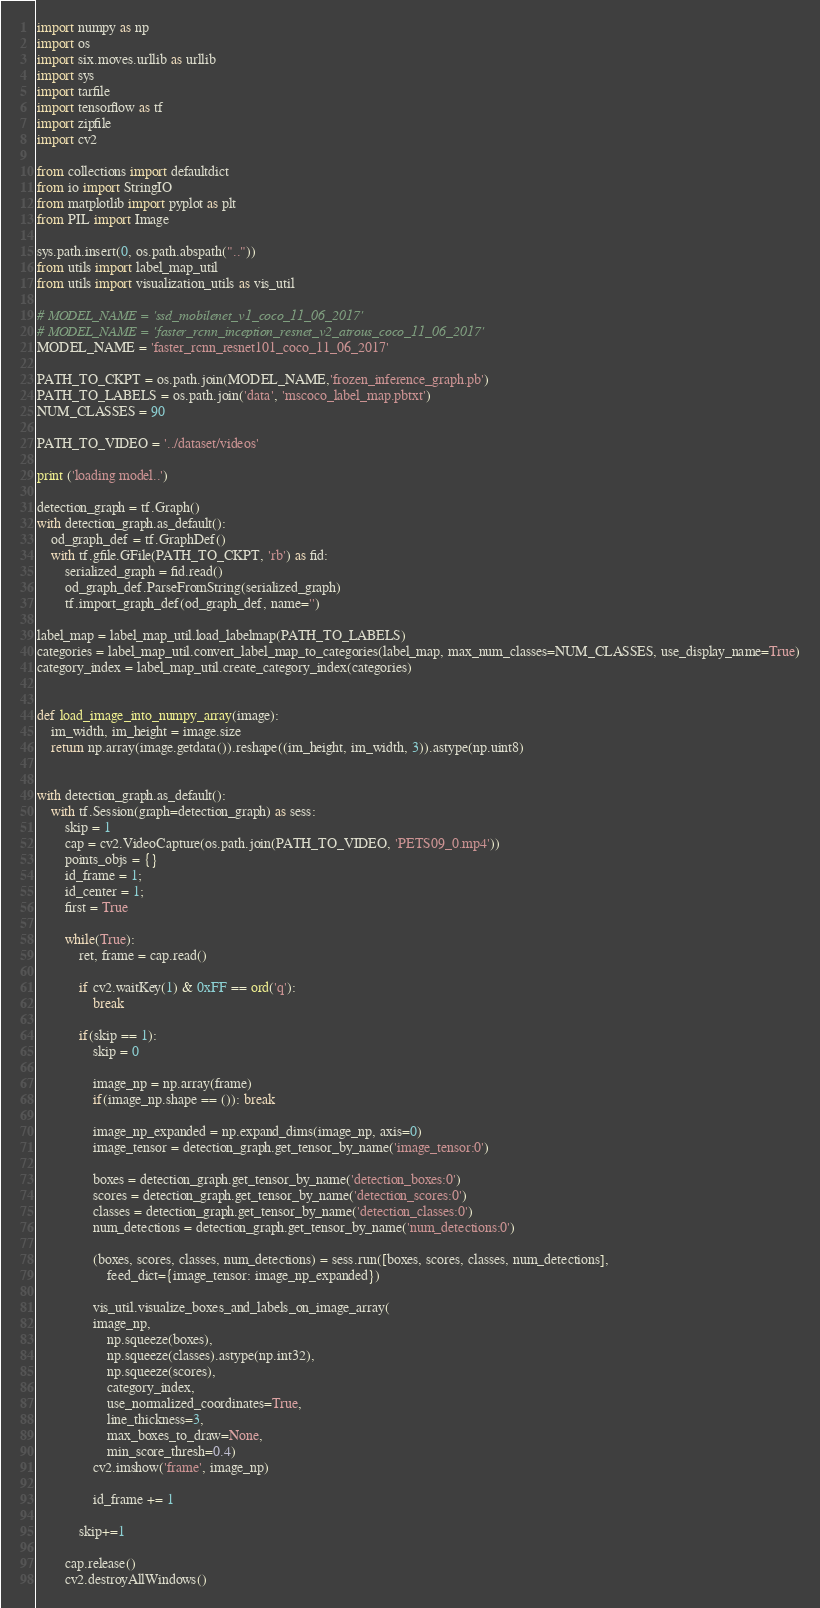Convert code to text. <code><loc_0><loc_0><loc_500><loc_500><_Python_>import numpy as np
import os
import six.moves.urllib as urllib
import sys
import tarfile
import tensorflow as tf
import zipfile
import cv2

from collections import defaultdict
from io import StringIO
from matplotlib import pyplot as plt
from PIL import Image

sys.path.insert(0, os.path.abspath(".."))
from utils import label_map_util
from utils import visualization_utils as vis_util

# MODEL_NAME = 'ssd_mobilenet_v1_coco_11_06_2017'
# MODEL_NAME = 'faster_rcnn_inception_resnet_v2_atrous_coco_11_06_2017'
MODEL_NAME = 'faster_rcnn_resnet101_coco_11_06_2017'

PATH_TO_CKPT = os.path.join(MODEL_NAME,'frozen_inference_graph.pb')
PATH_TO_LABELS = os.path.join('data', 'mscoco_label_map.pbtxt')
NUM_CLASSES = 90

PATH_TO_VIDEO = '../dataset/videos'

print ('loading model..')

detection_graph = tf.Graph()
with detection_graph.as_default():
	od_graph_def = tf.GraphDef()
	with tf.gfile.GFile(PATH_TO_CKPT, 'rb') as fid:
		serialized_graph = fid.read()
		od_graph_def.ParseFromString(serialized_graph)
		tf.import_graph_def(od_graph_def, name='')
	
label_map = label_map_util.load_labelmap(PATH_TO_LABELS)
categories = label_map_util.convert_label_map_to_categories(label_map, max_num_classes=NUM_CLASSES, use_display_name=True)
category_index = label_map_util.create_category_index(categories)


def load_image_into_numpy_array(image):
	im_width, im_height = image.size
	return np.array(image.getdata()).reshape((im_height, im_width, 3)).astype(np.uint8)


with detection_graph.as_default():
	with tf.Session(graph=detection_graph) as sess:
		skip = 1
		cap = cv2.VideoCapture(os.path.join(PATH_TO_VIDEO, 'PETS09_0.mp4'))
		points_objs = {}
		id_frame = 1;
		id_center = 1;
		first = True

		while(True):
			ret, frame = cap.read()

			if cv2.waitKey(1) & 0xFF == ord('q'):
				break

			if(skip == 1):
				skip = 0

				image_np = np.array(frame)
				if(image_np.shape == ()): break

				image_np_expanded = np.expand_dims(image_np, axis=0)
				image_tensor = detection_graph.get_tensor_by_name('image_tensor:0')
				
				boxes = detection_graph.get_tensor_by_name('detection_boxes:0')
				scores = detection_graph.get_tensor_by_name('detection_scores:0')
				classes = detection_graph.get_tensor_by_name('detection_classes:0')
				num_detections = detection_graph.get_tensor_by_name('num_detections:0')
				
				(boxes, scores, classes, num_detections) = sess.run([boxes, scores, classes, num_detections],
				    feed_dict={image_tensor: image_np_expanded})

				vis_util.visualize_boxes_and_labels_on_image_array(
				image_np,
					np.squeeze(boxes),
					np.squeeze(classes).astype(np.int32),
					np.squeeze(scores),
					category_index,
				    use_normalized_coordinates=True,
				    line_thickness=3,
					max_boxes_to_draw=None,
					min_score_thresh=0.4)
				cv2.imshow('frame', image_np)

				id_frame += 1

			skip+=1

		cap.release()
		cv2.destroyAllWindows()</code> 